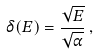<formula> <loc_0><loc_0><loc_500><loc_500>\delta ( E ) = \frac { \sqrt { E } } { \sqrt { \alpha } } \, ,</formula> 